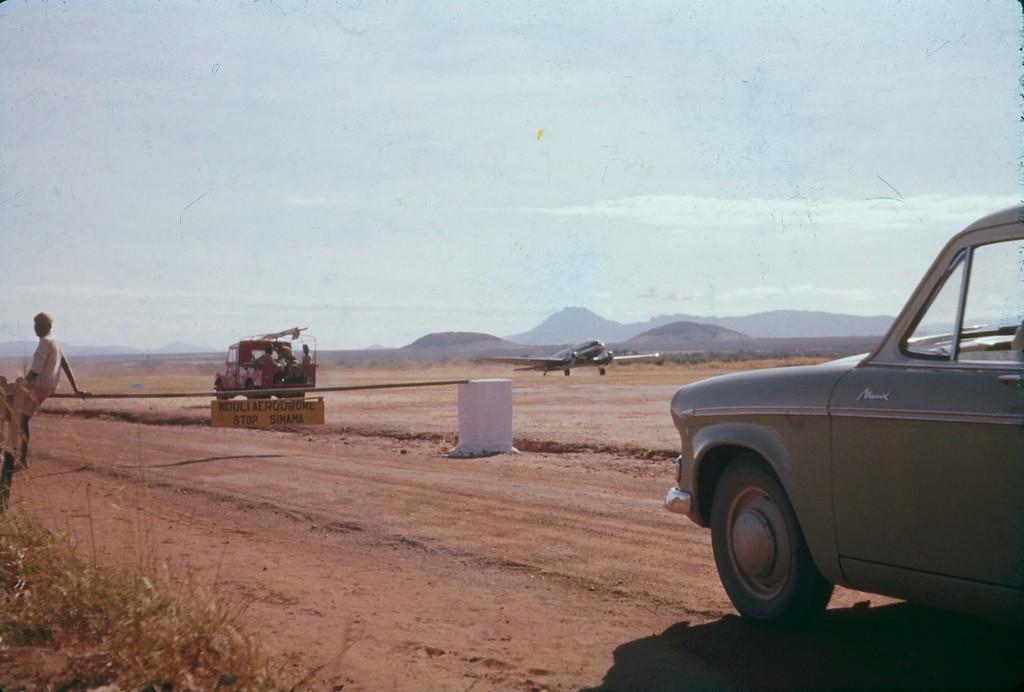In one or two sentences, can you explain what this image depicts? On the right side of the image we can grass, a person is sitting on a stick. In the middle of the image we can see there is a vehicle and board and a plane which is about to fly. There are mountains which are in a blur and we can also see the sky. On the right side of the image we can see a car. 